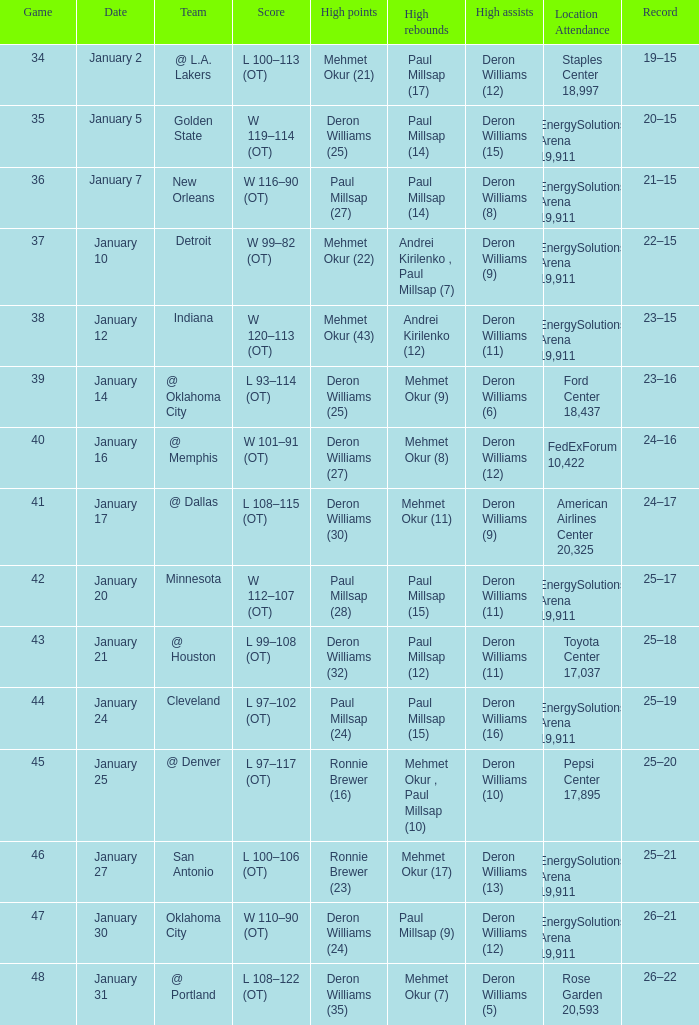Who secured the highest number of rebounds in the match where deron williams (5) led in assists? Mehmet Okur (7). 